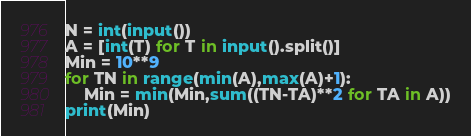Convert code to text. <code><loc_0><loc_0><loc_500><loc_500><_Python_>N = int(input())
A = [int(T) for T in input().split()]
Min = 10**9
for TN in range(min(A),max(A)+1):
    Min = min(Min,sum((TN-TA)**2 for TA in A))
print(Min)</code> 